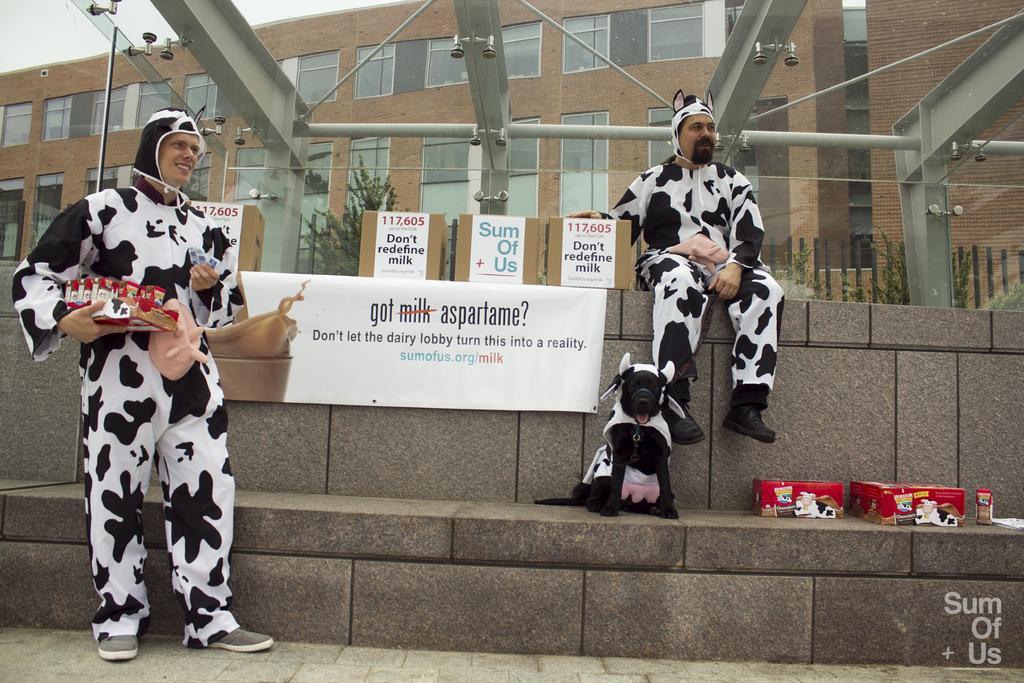Please provide a concise description of this image. The picture is taken outside a building. In the foreground of the picture there are boxes, banner, a dog and two men. In the background there is a building. At the top there is a glass ceiling. Sky is little bit cloudy. 